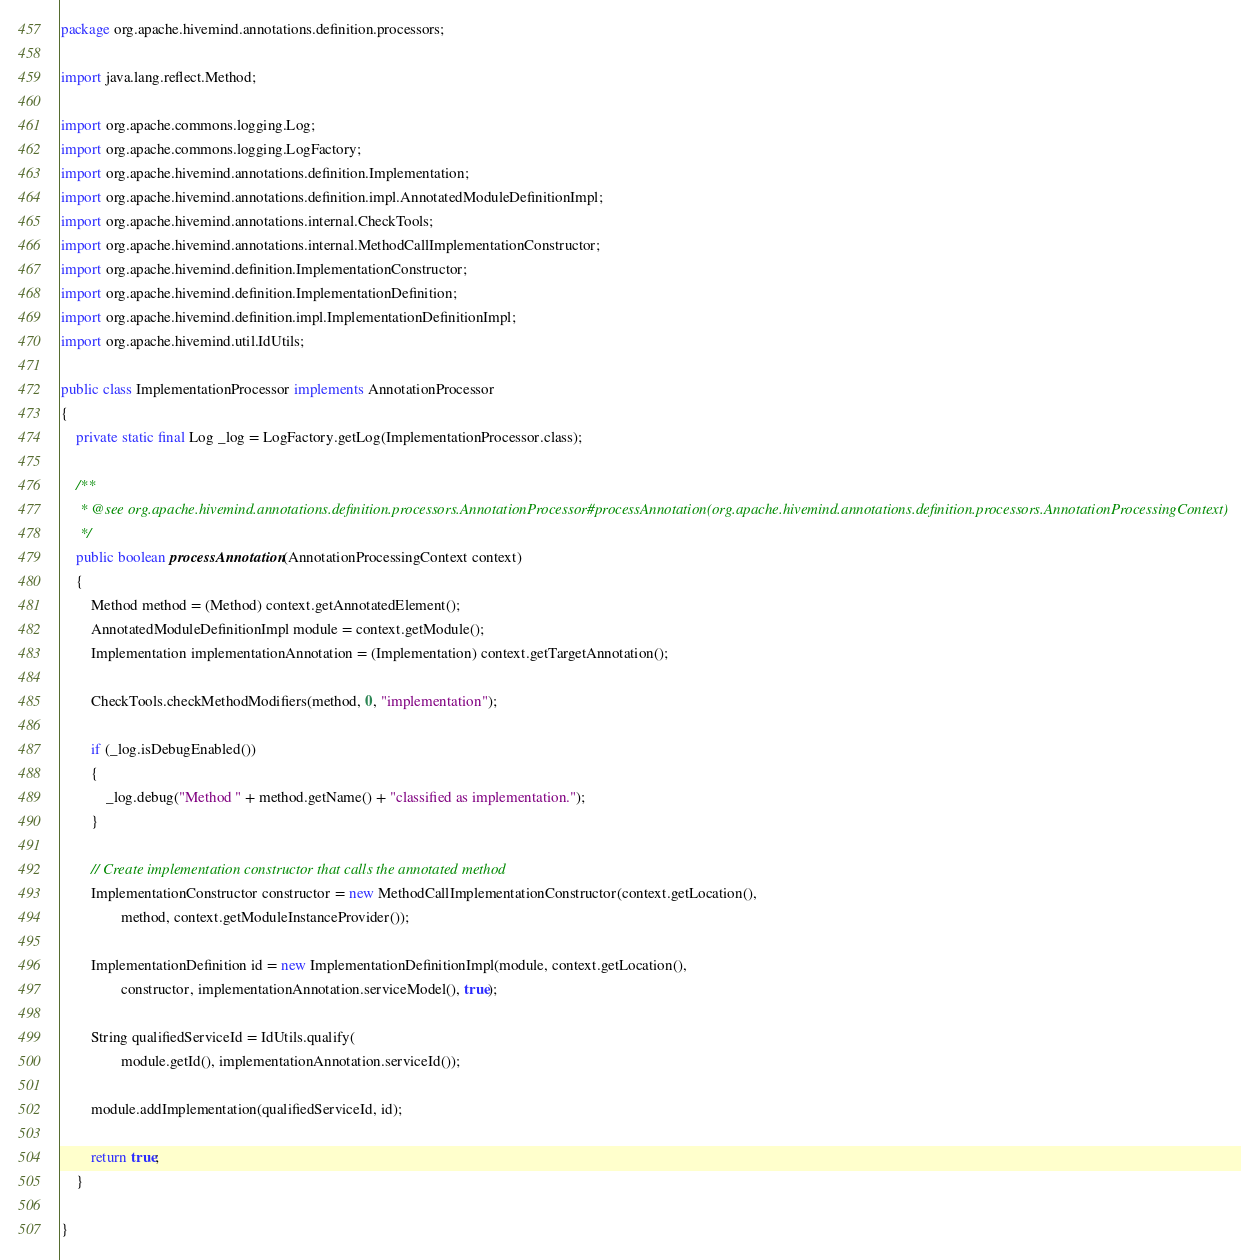Convert code to text. <code><loc_0><loc_0><loc_500><loc_500><_Java_>package org.apache.hivemind.annotations.definition.processors;

import java.lang.reflect.Method;

import org.apache.commons.logging.Log;
import org.apache.commons.logging.LogFactory;
import org.apache.hivemind.annotations.definition.Implementation;
import org.apache.hivemind.annotations.definition.impl.AnnotatedModuleDefinitionImpl;
import org.apache.hivemind.annotations.internal.CheckTools;
import org.apache.hivemind.annotations.internal.MethodCallImplementationConstructor;
import org.apache.hivemind.definition.ImplementationConstructor;
import org.apache.hivemind.definition.ImplementationDefinition;
import org.apache.hivemind.definition.impl.ImplementationDefinitionImpl;
import org.apache.hivemind.util.IdUtils;

public class ImplementationProcessor implements AnnotationProcessor
{
    private static final Log _log = LogFactory.getLog(ImplementationProcessor.class);

    /**
     * @see org.apache.hivemind.annotations.definition.processors.AnnotationProcessor#processAnnotation(org.apache.hivemind.annotations.definition.processors.AnnotationProcessingContext)
     */
    public boolean processAnnotation(AnnotationProcessingContext context)
    {
        Method method = (Method) context.getAnnotatedElement();
        AnnotatedModuleDefinitionImpl module = context.getModule();
        Implementation implementationAnnotation = (Implementation) context.getTargetAnnotation(); 
        
        CheckTools.checkMethodModifiers(method, 0, "implementation");
        
        if (_log.isDebugEnabled())
        {
            _log.debug("Method " + method.getName() + "classified as implementation.");
        }
        
        // Create implementation constructor that calls the annotated method 
        ImplementationConstructor constructor = new MethodCallImplementationConstructor(context.getLocation(), 
                method, context.getModuleInstanceProvider());

        ImplementationDefinition id = new ImplementationDefinitionImpl(module, context.getLocation(), 
                constructor, implementationAnnotation.serviceModel(), true);
        
        String qualifiedServiceId = IdUtils.qualify(
                module.getId(), implementationAnnotation.serviceId());

        module.addImplementation(qualifiedServiceId, id);

        return true;
    }

}
</code> 